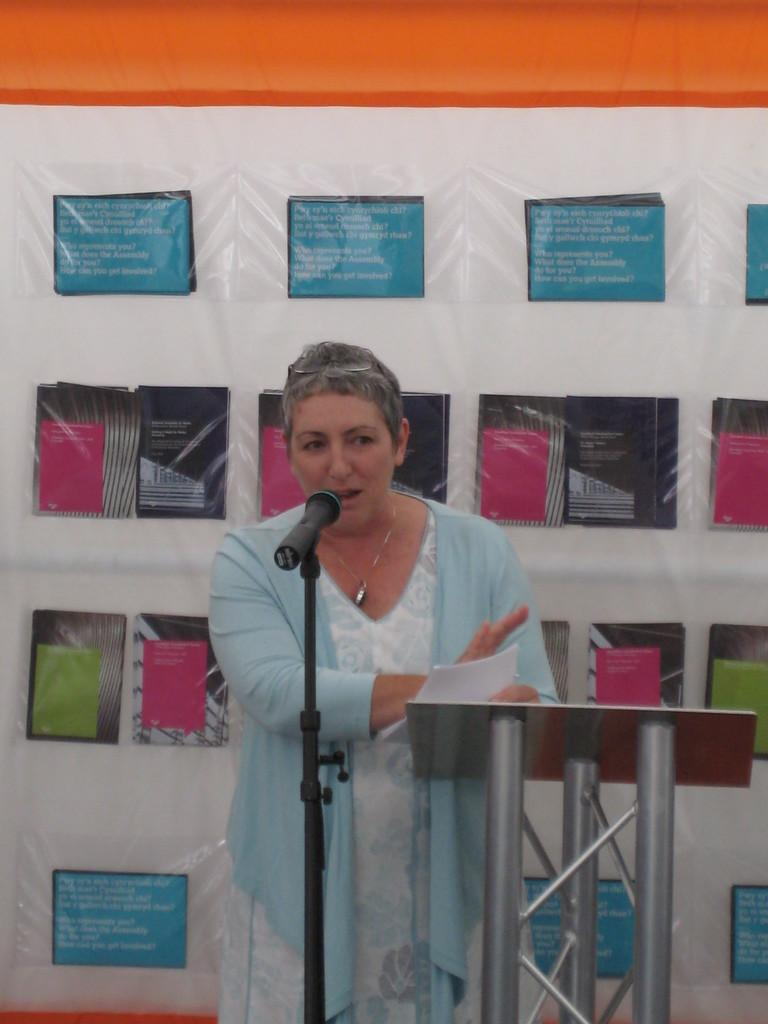What is the person in the image doing? The person is standing in the image and holding papers. What object is the person likely to use for speaking or presenting? There is a microphone in the image, which the person might use for speaking or presenting. Is there any support for the microphone in the image? Yes, there is a stand for the microphone in the image. What can be seen in the background of the image? There is a banner with text and images in the background. What type of branch can be seen growing from the microphone in the image? There is no branch growing from the microphone in the image; it is a microphone stand with no plant life present. 